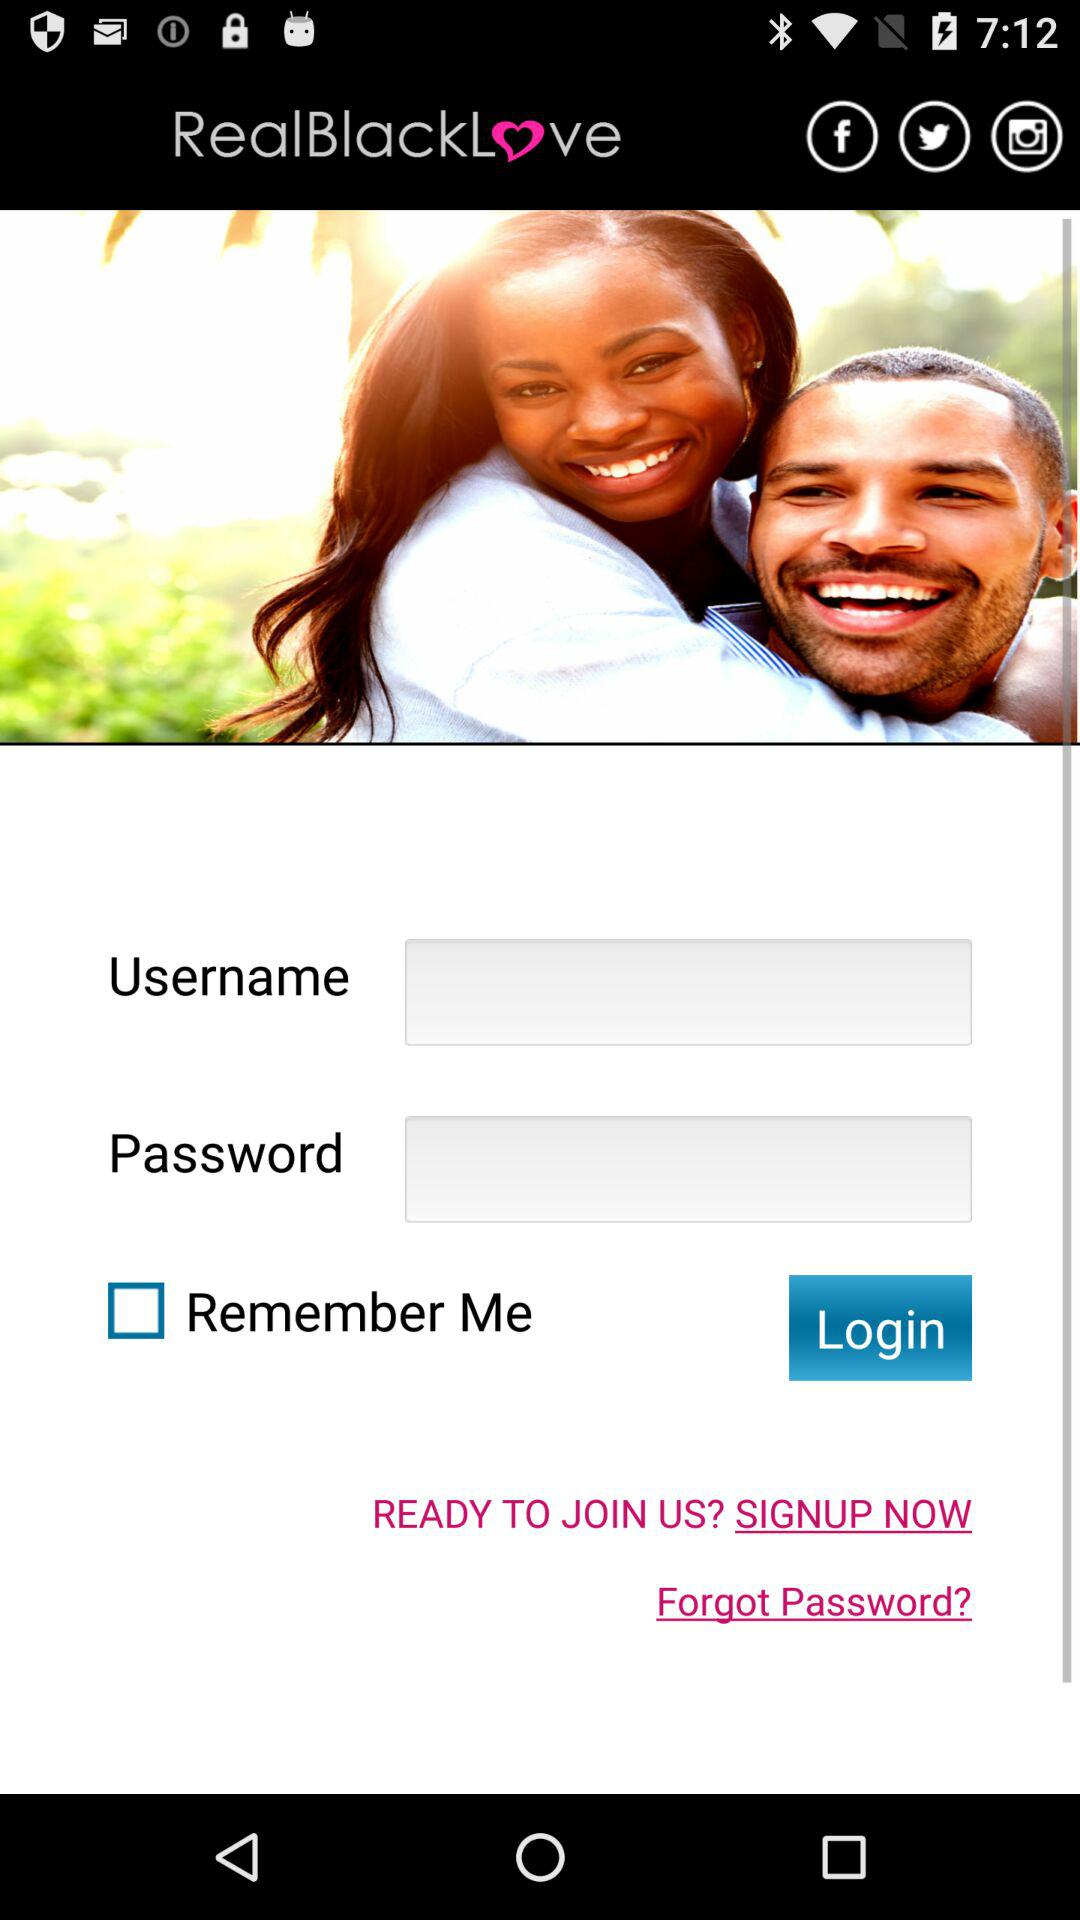Through which application can the user log in? The user can log in through "Facebook", "Twitter" and "Instagram". 